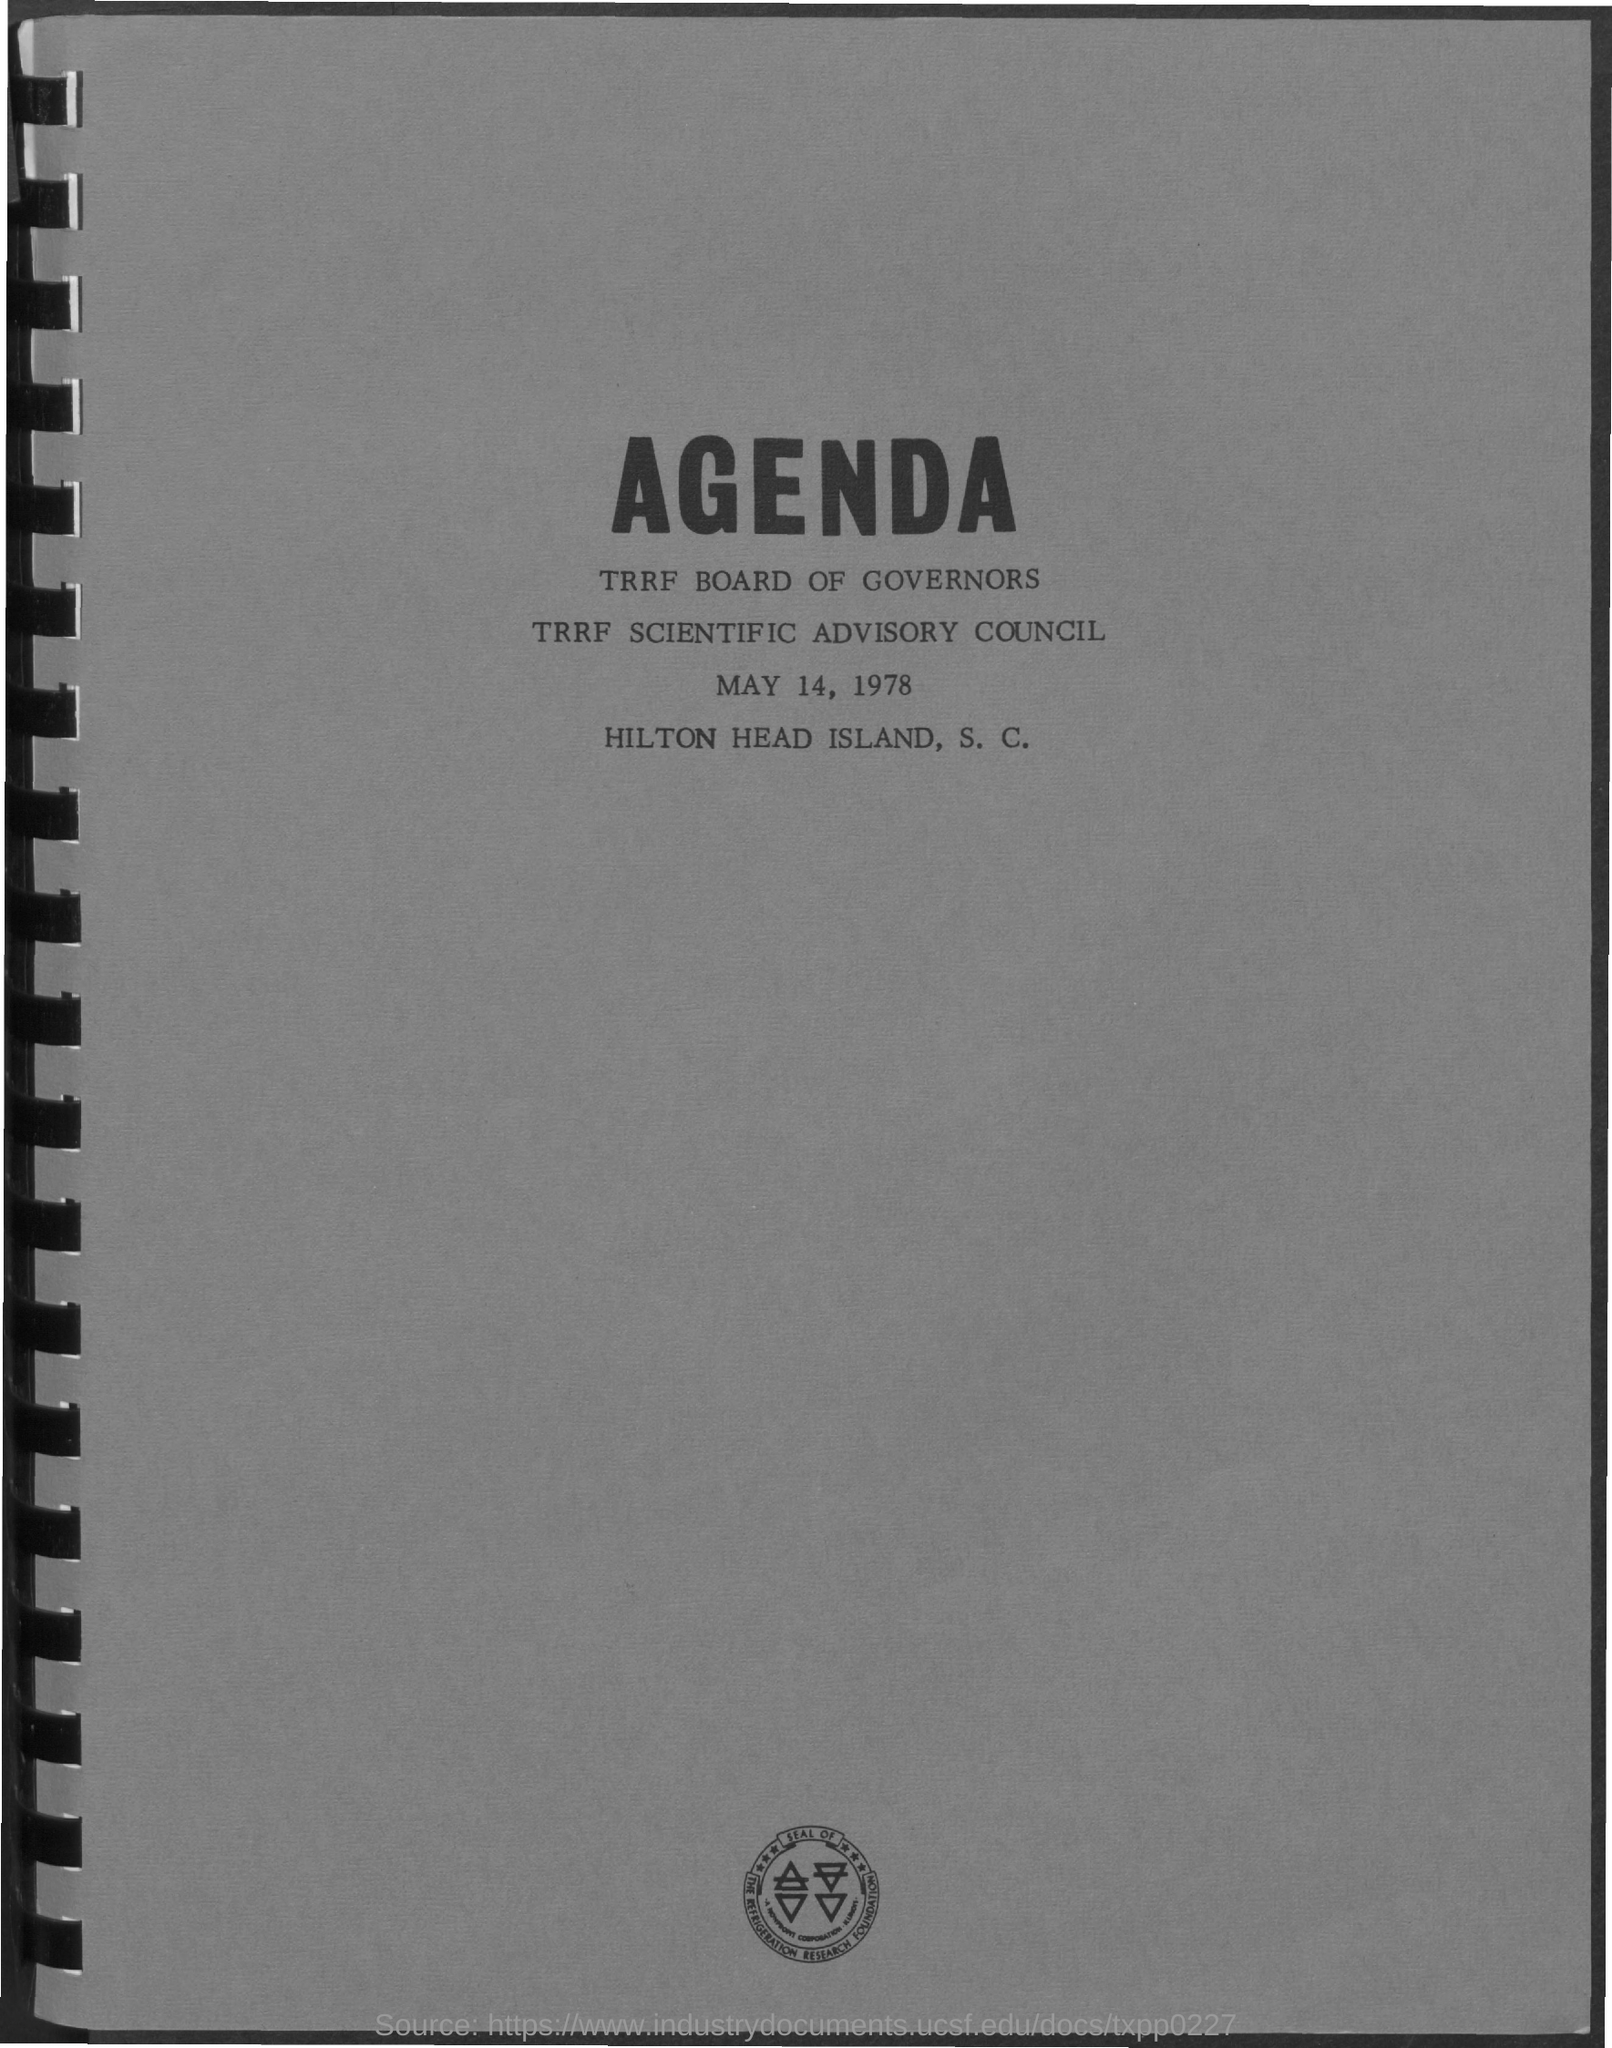What is the date on the document?
Your response must be concise. MAY 14, 1978. 